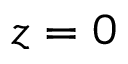<formula> <loc_0><loc_0><loc_500><loc_500>z = 0</formula> 